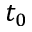<formula> <loc_0><loc_0><loc_500><loc_500>t _ { 0 }</formula> 